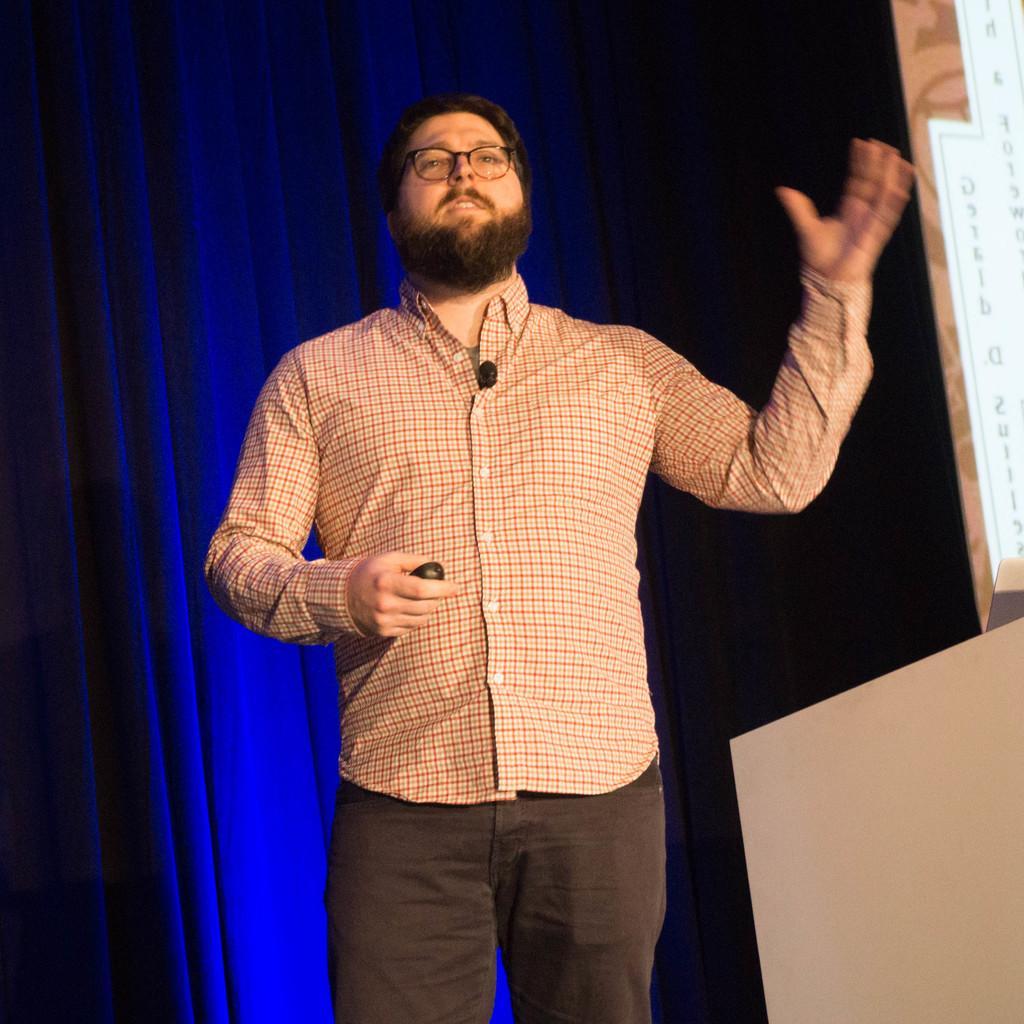Please provide a concise description of this image. In this image we can see a man wearing specs and he is holding something in the hand. In the back there is curtain. On the right side there is a board with text. 